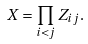Convert formula to latex. <formula><loc_0><loc_0><loc_500><loc_500>X = \prod _ { i < j } Z _ { i j } .</formula> 